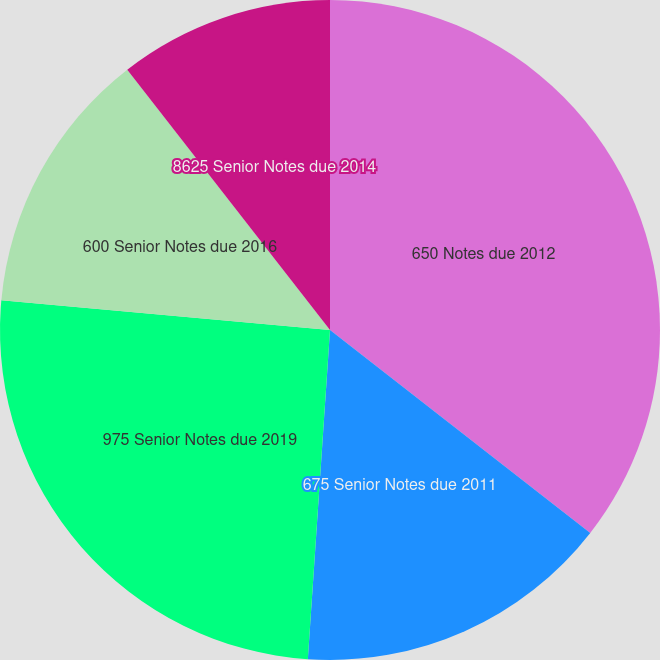Convert chart. <chart><loc_0><loc_0><loc_500><loc_500><pie_chart><fcel>650 Notes due 2012<fcel>675 Senior Notes due 2011<fcel>975 Senior Notes due 2019<fcel>600 Senior Notes due 2016<fcel>8625 Senior Notes due 2014<nl><fcel>35.54%<fcel>15.53%<fcel>25.37%<fcel>13.03%<fcel>10.53%<nl></chart> 